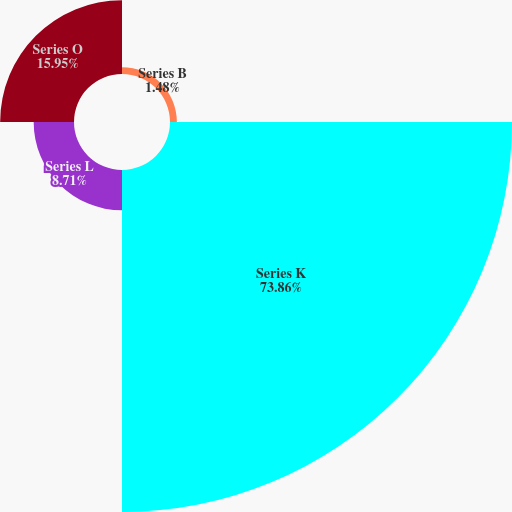<chart> <loc_0><loc_0><loc_500><loc_500><pie_chart><fcel>Series B<fcel>Series K<fcel>Series L<fcel>Series O<nl><fcel>1.48%<fcel>73.86%<fcel>8.71%<fcel>15.95%<nl></chart> 